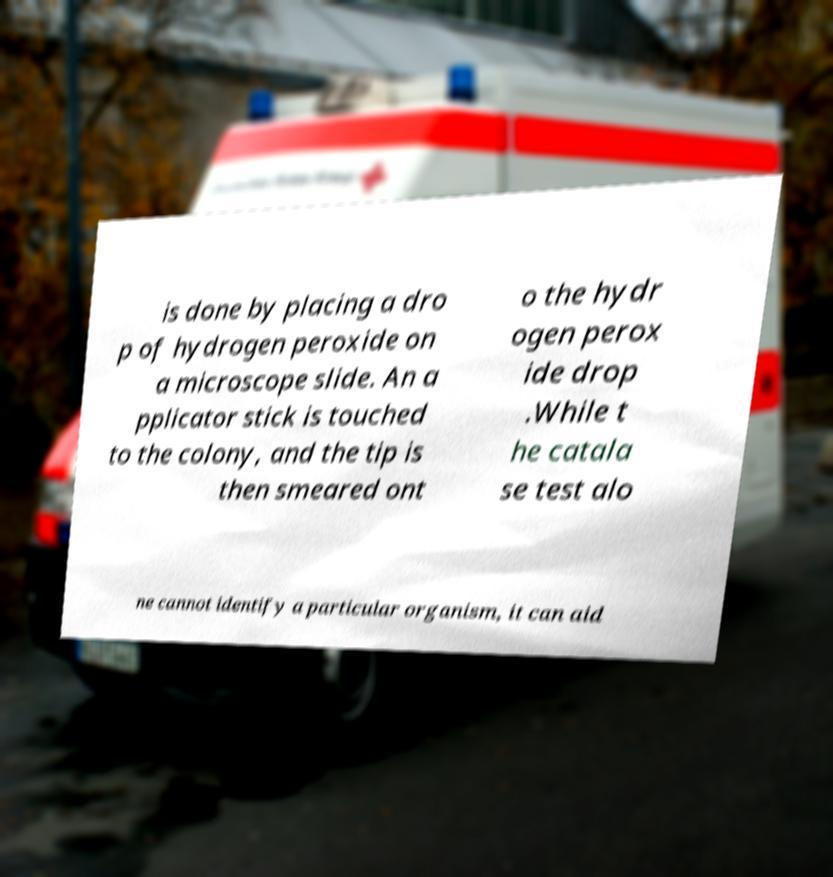Could you assist in decoding the text presented in this image and type it out clearly? is done by placing a dro p of hydrogen peroxide on a microscope slide. An a pplicator stick is touched to the colony, and the tip is then smeared ont o the hydr ogen perox ide drop .While t he catala se test alo ne cannot identify a particular organism, it can aid 